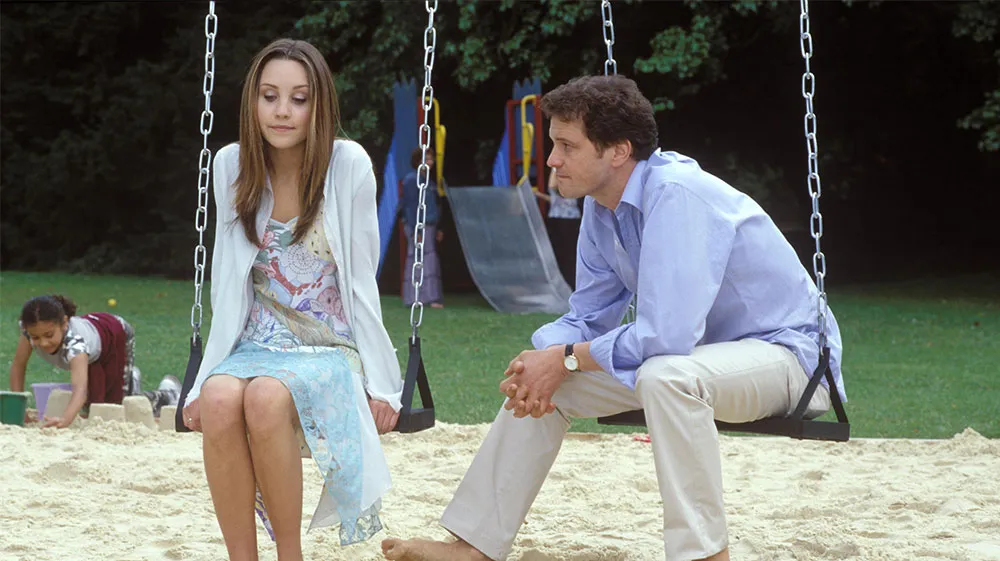What might be the relationship between the two individuals and how does the setting influence this perception? The two individuals appear to share a close and possibly intimate relationship, indicated by their comfortable body language and the private nature of their setting in a public park. The choice of a playground, typically associated with childhood and carefree days, might suggest a discussion filled with reminiscence or a comfortable, informal setting to share personal thoughts and feelings. It adds a layer of casualness and nostalgia to their interaction, potentially deepening their emotional connection. 